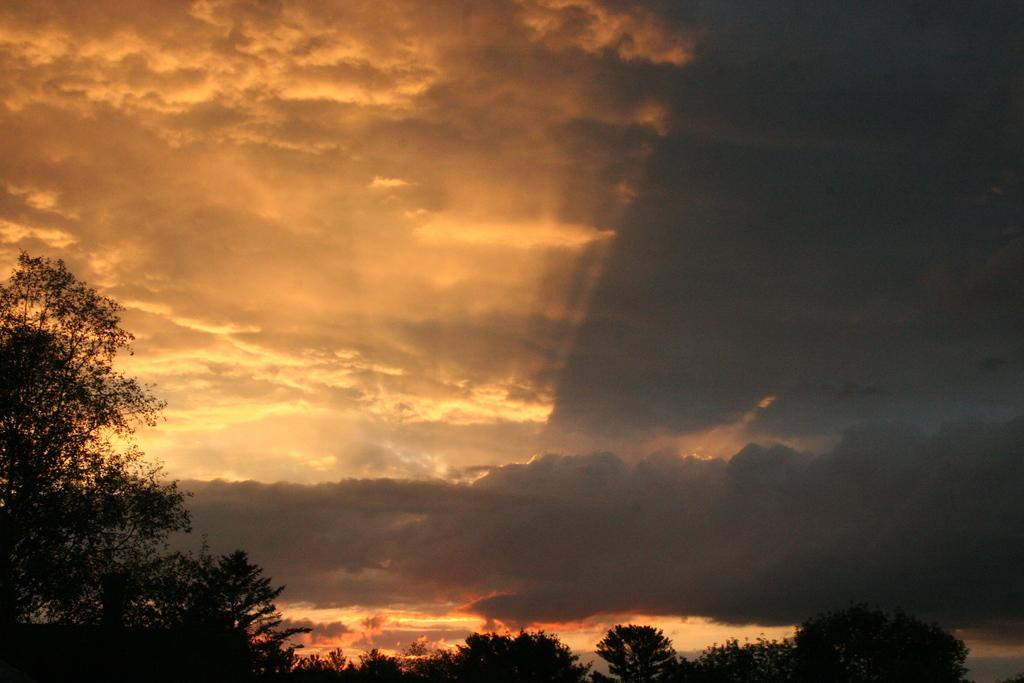What type of vegetation can be seen in the image? There are trees in the image. What is visible in the background of the image? The sky is visible in the image. What colors can be seen in the sky? The sky has orange, black, and white colors. How many geese are sitting on the table in the image? There are no geese or tables present in the image. What type of detail can be seen on the geese in the image? There are no geese in the image, so there is no detail to describe. 